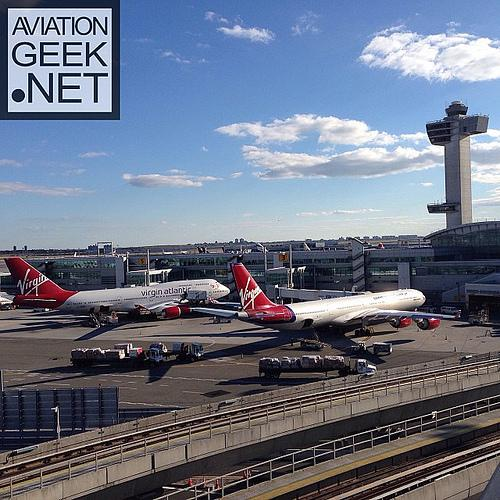Mention some specific features of the planes visible in the image. The planes have red and white color schemes, with two jet engines mounted under each wing and a word written on their tails. Explain the main focus of the image along with some background elements. The image focuses on two parked airplanes with a passenger terminal, air traffic control tower, and cloudy blue sky in the background. Identify the location of the passenger terminal in the image. The passenger terminal is located in the background of the image, behind the parked planes. In one sentence, describe the setting where the planes are located. The airplanes are parked on the tarmac of an airport, alongside loading equipment and airport infrastructure. Provide a brief, concise overview of the image's content. Two planes are parked on the tarmac near a passenger terminal, with white clouds in a blue sky above. Describe the scene involving luggage in the image. Luggage is being prepared for loading in the cargo bay on the tarmac among various parked vehicles and equipment. Mention the position and color of the runways. The runway is depicted in the lower part of the image, with a dark surface marked by lines. Highlight the attributes of the sky in the image. The sky is a vibrant blue with white, puffy clouds scattered throughout, offering a picturesque backdrop. Describe the role of the air traffic control tower in the image. The air traffic control tower is visible in the image, overseeing operations near the parked planes and passenger terminal. Characterize the atmosphere and environment in the image. The image portrays a bustling airport scene with parked planes, loading vehicles, and an air traffic control tower, set underneath a blue, cloudy sky. 